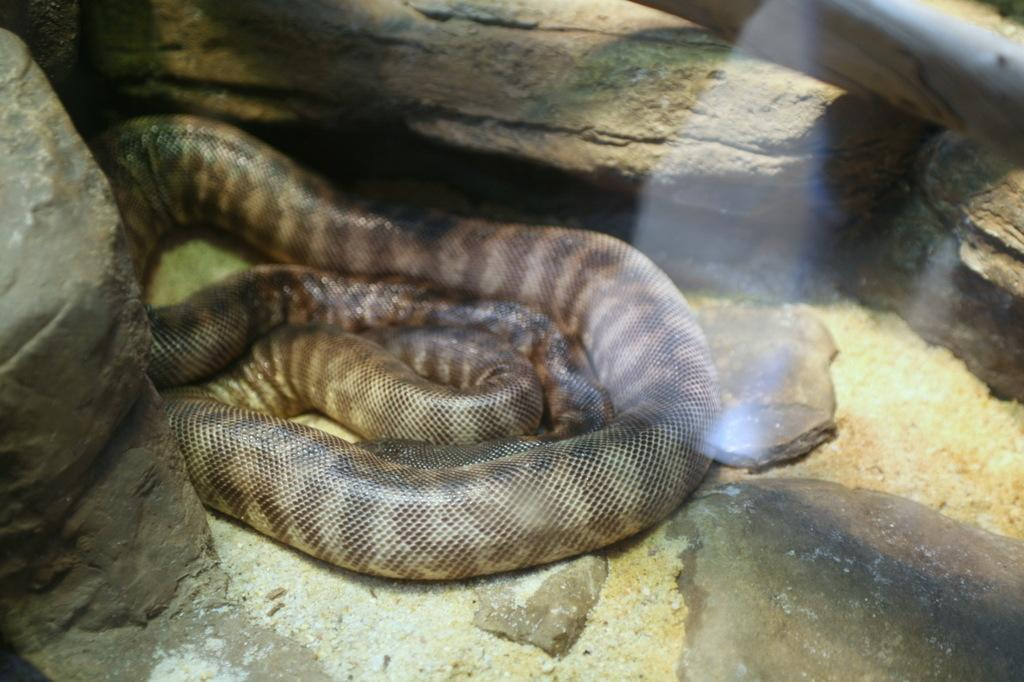What type of animal is on the ground in the image? There is a snake on the ground in the image. What other objects can be seen in the image besides the snake? There are rocks and glass visible in the image. What is the opinion of the snake about the plate in the image? There is no plate present in the image, and therefore the snake's opinion about a plate cannot be determined. What type of field is visible in the image? There is no field visible in the image; it features a snake, rocks, and glass. 